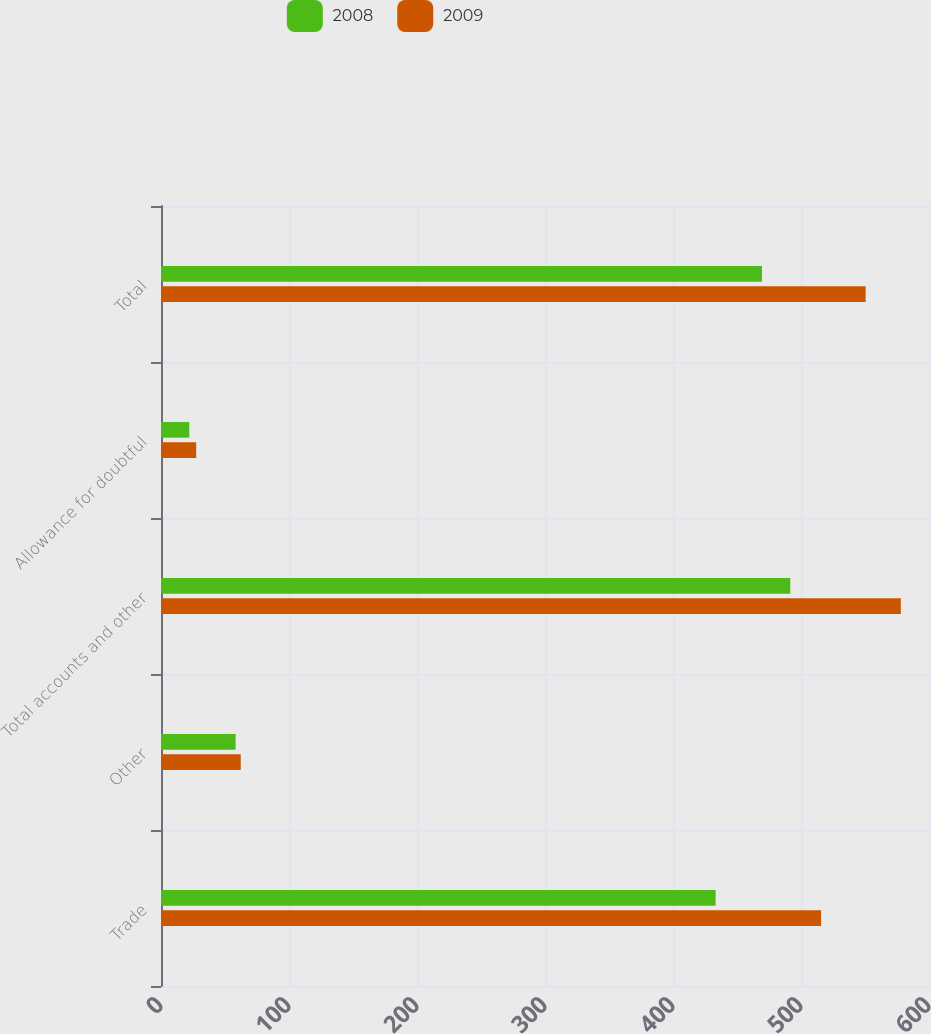Convert chart to OTSL. <chart><loc_0><loc_0><loc_500><loc_500><stacked_bar_chart><ecel><fcel>Trade<fcel>Other<fcel>Total accounts and other<fcel>Allowance for doubtful<fcel>Total<nl><fcel>2008<fcel>433.3<fcel>58.3<fcel>491.6<fcel>22.1<fcel>469.5<nl><fcel>2009<fcel>515.7<fcel>62.3<fcel>578<fcel>27.5<fcel>550.5<nl></chart> 